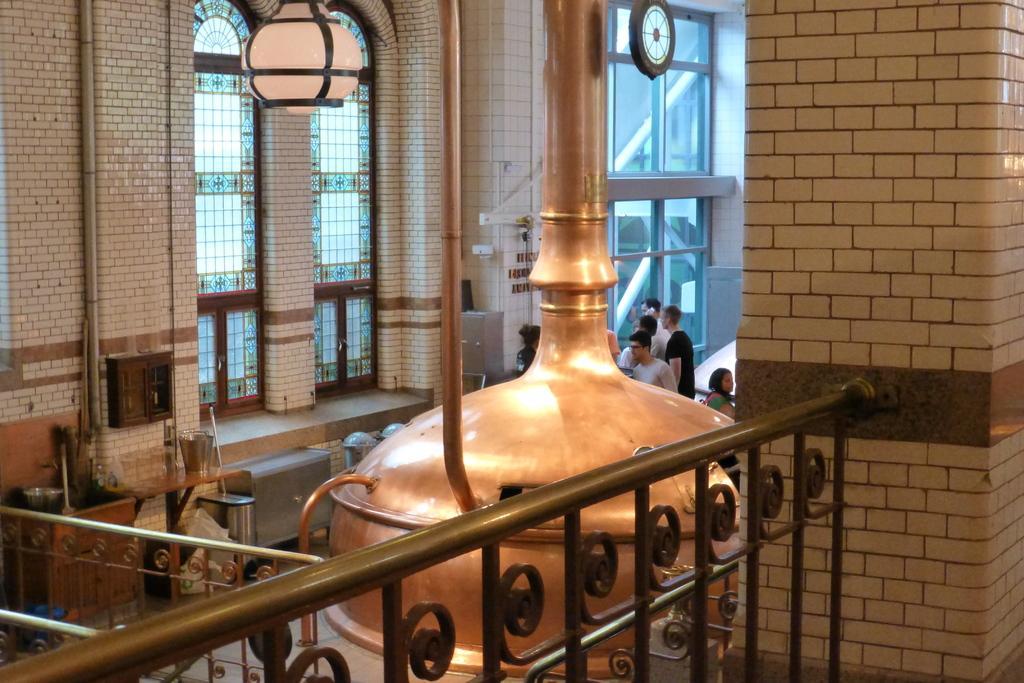Describe this image in one or two sentences. In the image I can see fence, people and some other objects on the ground. In the background I can see framed glass wall, pipes attached to the wall and some other objects. 